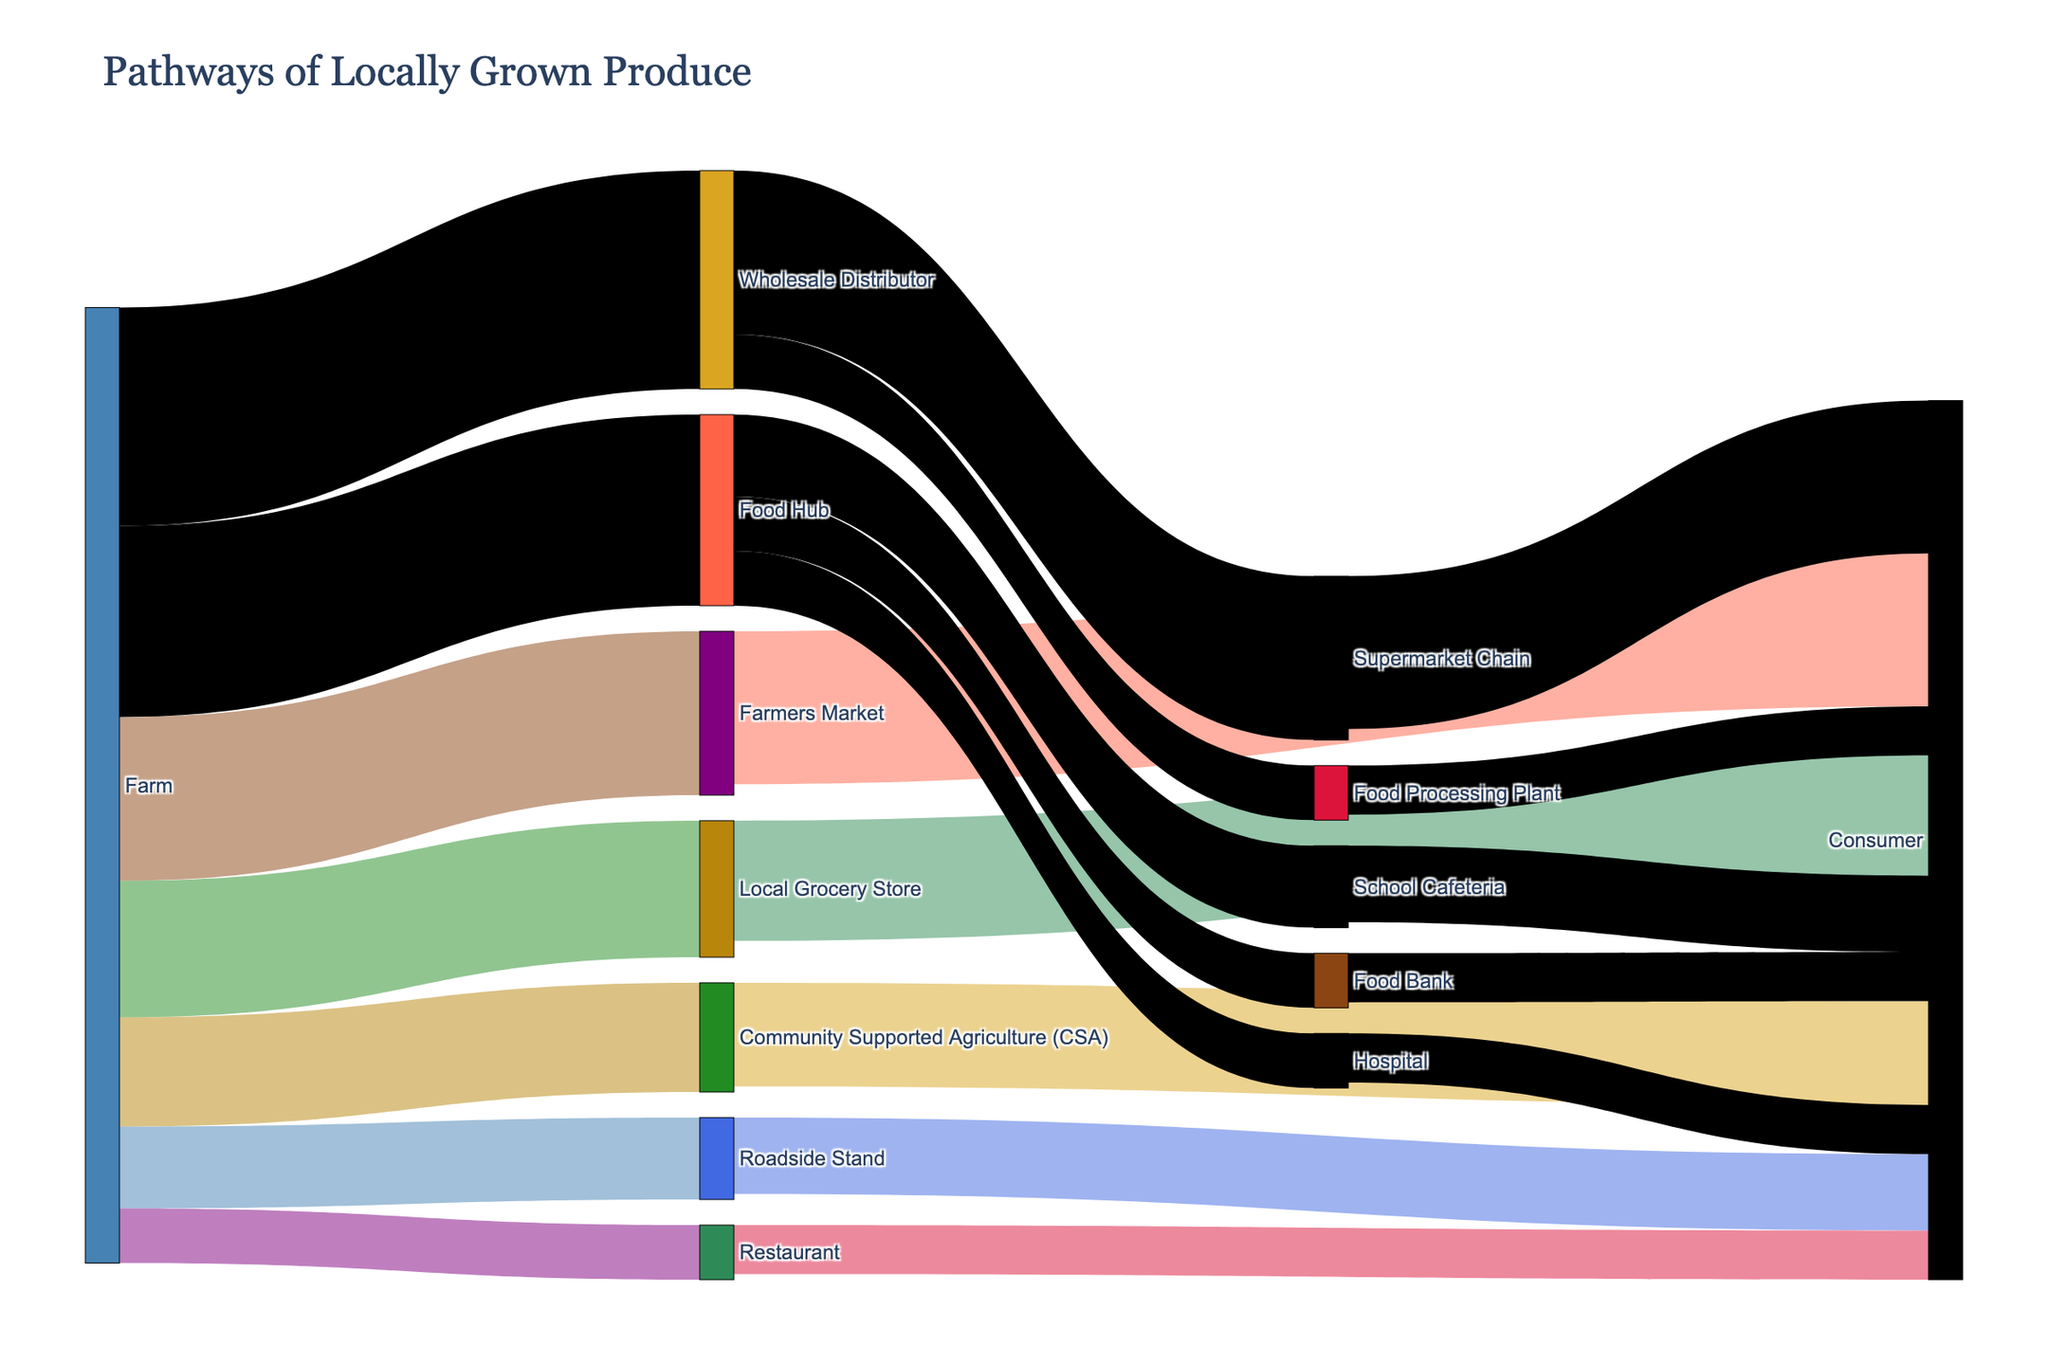What's the title of the figure? The title can usually be found at the top of the figure. It is meant to give a clear idea of what the diagram represents. In this case, it should be located at the top center.
Answer: Pathways of Locally Grown Produce How many different end consumer destinations are represented in the Sankey Diagram? To find the end consumer destinations, look at the far right side of the diagram where all the final nodes are connected. Count each unique destination.
Answer: 5 Which distribution channel from the 'Farm' node contributes the most throughput to 'Consumer'? To answer this, find the node representing 'Farm' and identify which channel has the thickest line leading to 'Consumer.' Thicker lines represent higher values.
Answer: Wholesale Distributor How much produce does the 'Farmers Market' distribute to 'Consumer'? Locate the line connecting 'Farmers Market' to 'Consumer' and note the number representing the value along the line.
Answer: 28 Compare the total value of produce distributed directly from 'Farm' to 'Consumer' to that distributed via 'Food Hub'. Which is higher? Add up the distribution values directly from 'Farm' to 'Consumer' and compare it with the sum of values passing through 'Food Hub'. Direct route is 0 (no direct line), via 'Food Hub' is 14 + 9 + 9 = 32.
Answer: Food Hub is higher What are the top three intermediate nodes, by value, through which produce passes before reaching the consumer? Review the nodes between 'Farm' and 'Consumer', summing individual contributions to consumer destinations. Identify the top three by their total.
Answer: Wholesale Distributor, Food Hub, Farmers Market Which distribution channel from 'Farm' to 'Consumer' involves the fewest intermediate steps? Examine the sequence of nodes from 'Farm' to 'Consumer'. The path with the least number of nodes in-between represents the shortest route.
Answer: Farmers Market How much produce reaches 'Consumer' via the 'Local Grocery Store' and 'Supermarket Chain' channels combined? Add the values distributed from 'Local Grocery Store' to 'Consumer' and 'Supermarket Chain' to 'Consumer'. Look for the values along these paths.
Answer: 22 + 28 = 50 What percentage of produce from 'Farm' ends up at 'Restaurant' before reaching 'Consumer'? Find total produce from 'Farm' (sum all distribution values), and the portion going to 'Restaurant'. Calculate (value to 'Restaurant' / total 'Farm' produce) and convert to percentage.
Answer: (10 / (30+25+20+15+10+35+40)) * 100 ≈ 6.17% Among the listed distribution channels, which one has the lowest direct transfer value from 'Farm' to an intermediate node? Look at the lines directly linking 'Farm' to other nodes. Identify the smallest value among them.
Answer: Restaurant 